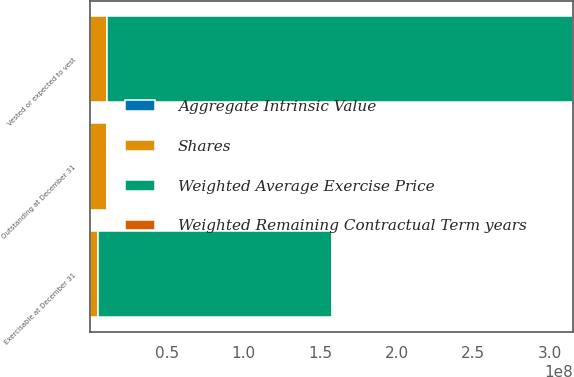Convert chart to OTSL. <chart><loc_0><loc_0><loc_500><loc_500><stacked_bar_chart><ecel><fcel>Outstanding at December 31<fcel>Vested or expected to vest<fcel>Exercisable at December 31<nl><fcel>Shares<fcel>1.10395e+07<fcel>1.067e+07<fcel>5.06719e+06<nl><fcel>Weighted Remaining Contractual Term years<fcel>38.01<fcel>38.01<fcel>36.31<nl><fcel>Aggregate Intrinsic Value<fcel>7.27<fcel>7.27<fcel>5.69<nl><fcel>Weighted Average Exercise Price<fcel>38.01<fcel>3.04394e+08<fcel>1.52742e+08<nl></chart> 